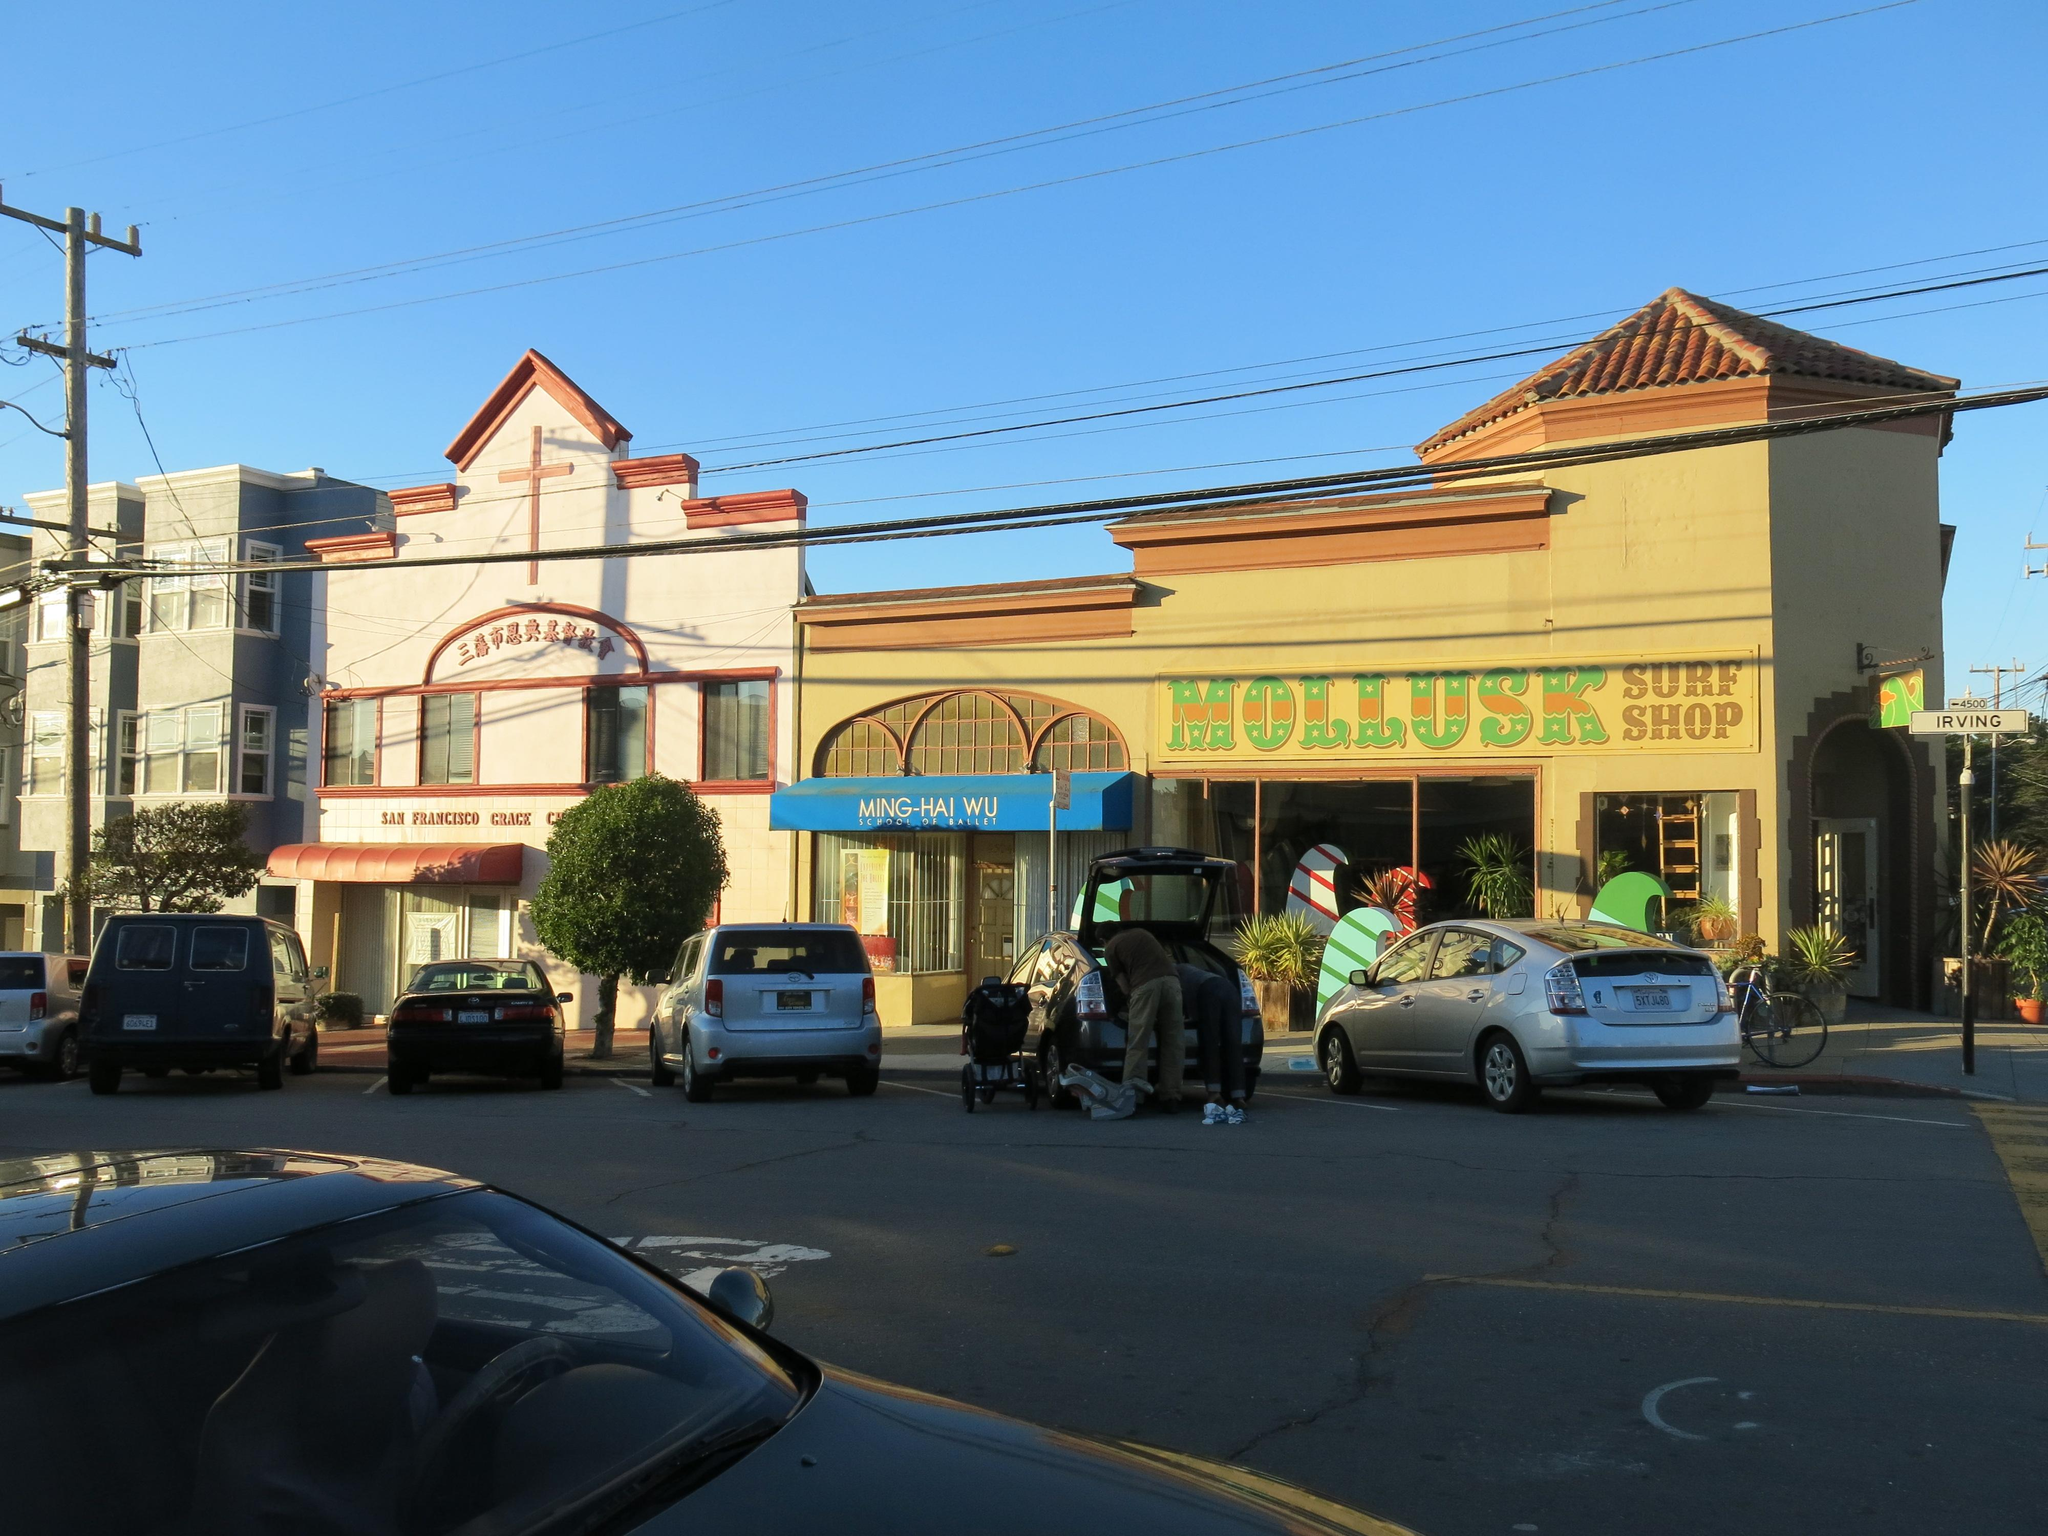What type of structures can be seen in the image? There are buildings in the image. What feature do the buildings have? The buildings have plants. What else can be seen near the buildings? Vehicles are parked in front of the buildings. What else is present in the image? There is a pole with wires attached in the image. Where is the car located in the image? A car is present in the left corner of the image. What arithmetic problem is being solved by the giants in the image? There are no giants or arithmetic problems present in the image. 